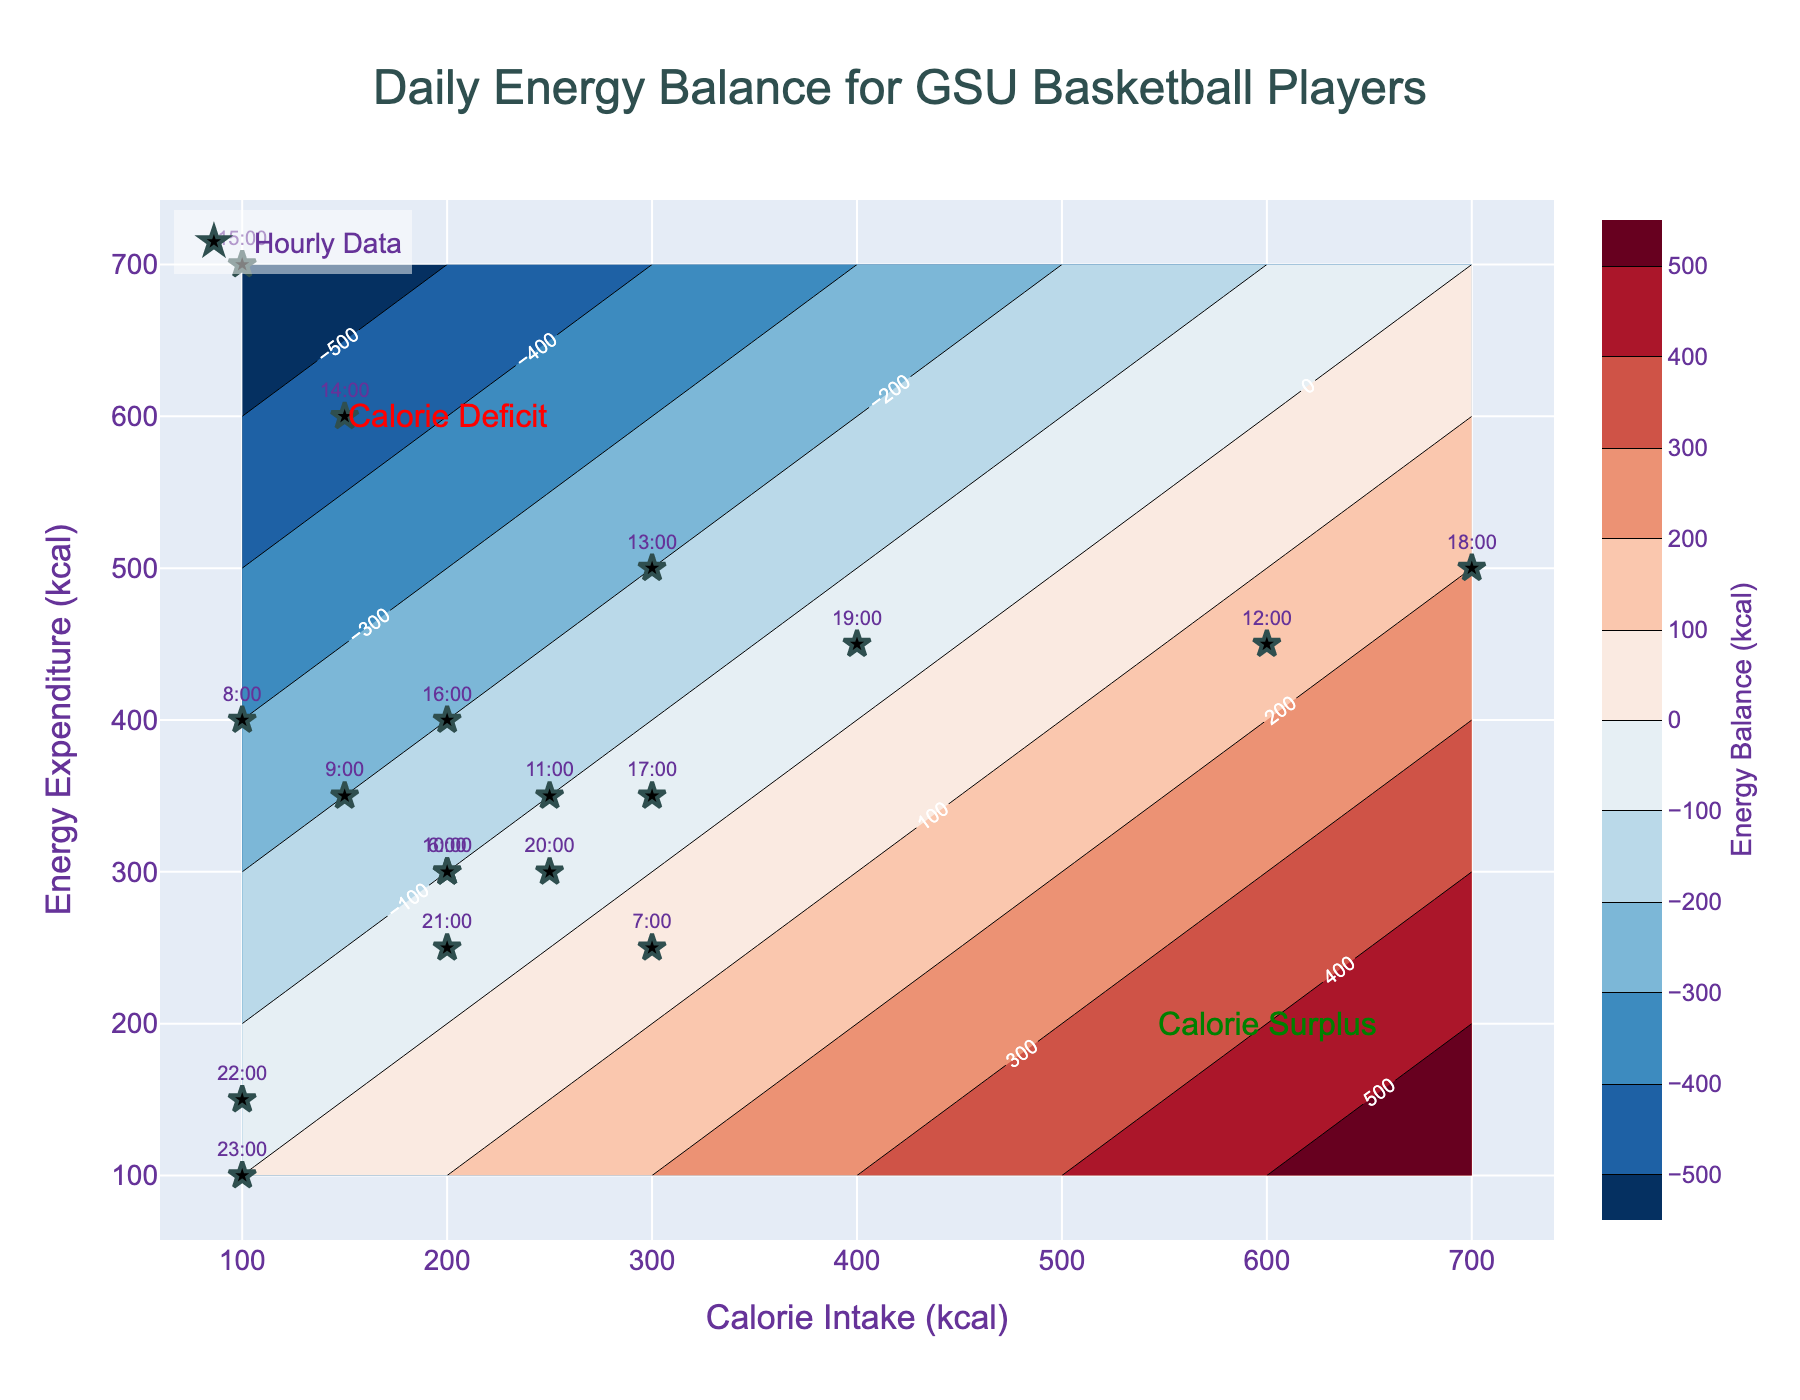what is the title of the plot? The title is usually located at the top of the figure. For this plot, the title reads "Daily Energy Balance for GSU Basketball Players".
Answer: Daily Energy Balance for GSU Basketball Players how many data points are plotted on the figure? Data points are depicted as 'star' markers with text annotations (times). By counting these markers, there are 18 data points plotted on the figure.
Answer: 18 what time shows a calorie surplus and how is it represented on the plot? Calorie surplus corresponds to regions where calorie intake is greater than energy expenditure. This can be seen in regions shifting towards the "Calorie Surplus" annotation. The scatter points that reflect this are 6:00, 7:00, 12:00, 18:00, and 19:00. Look for these specific times around the 'Calorie Surplus' area.
Answer: 6:00, 7:00, 12:00, 18:00, and 19:00 which hour shows the largest calorie deficit? To determine this, look for the time when the energy expenditure is significantly greater than caloric intake. At 15:00, the energy expenditure is 700 kcal, and the intake is only 100 kcal, showing a stark calorie deficit.
Answer: 15:00 how many labels with 'Calorie Intake (kcal)' are shown on the x-axis? The x-axis contains labels that are the 'Calorie Intake (kcal)'. By counting these labels, you will see there are 13 of them, with values ranging from approximately 0 to 700 kcal.
Answer: 13 which hour has both the calorie intake and energy expenditure closest to 450 kcal? Compare the hour labels and find the ones near the values closest to 450 kcal. The time that fits this condition is 19:00, where the intake is 400 kcal and expenditure is 450 kcal, both values are quite close to 450 kcal.
Answer: 19:00 what are the coordinates of the point labeled 9:00? Locate the point marked as 9:00 on the plot. It corresponds to 150 kcal intake on the x-axis and 350 kcal expenditure on the y-axis.
Answer: (150, 350) which hour has the smallest difference between calorie intake and energy expenditure? Identify the times with the smallest difference by comparing each data point. At 23:00, both calorie intake and energy expenditure are equal at 100 kcal, giving a difference of 0.
Answer: 23:00 between the hours of 8:00 and 14:00, which shows the highest energy expenditure? Analyze the data points between these hours. 14:00 has the highest energy expenditure at 600 kcal.
Answer: 14:00 